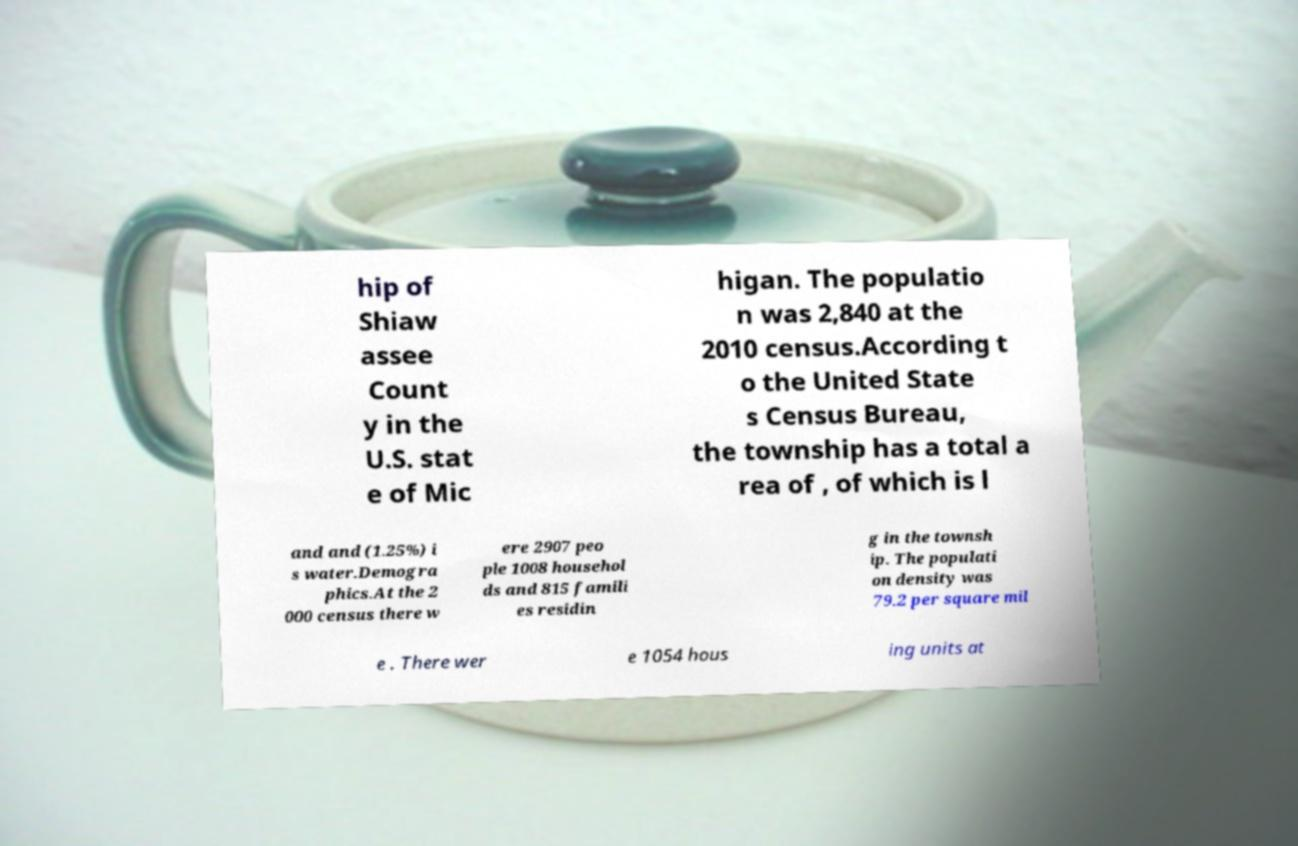I need the written content from this picture converted into text. Can you do that? hip of Shiaw assee Count y in the U.S. stat e of Mic higan. The populatio n was 2,840 at the 2010 census.According t o the United State s Census Bureau, the township has a total a rea of , of which is l and and (1.25%) i s water.Demogra phics.At the 2 000 census there w ere 2907 peo ple 1008 househol ds and 815 famili es residin g in the townsh ip. The populati on density was 79.2 per square mil e . There wer e 1054 hous ing units at 